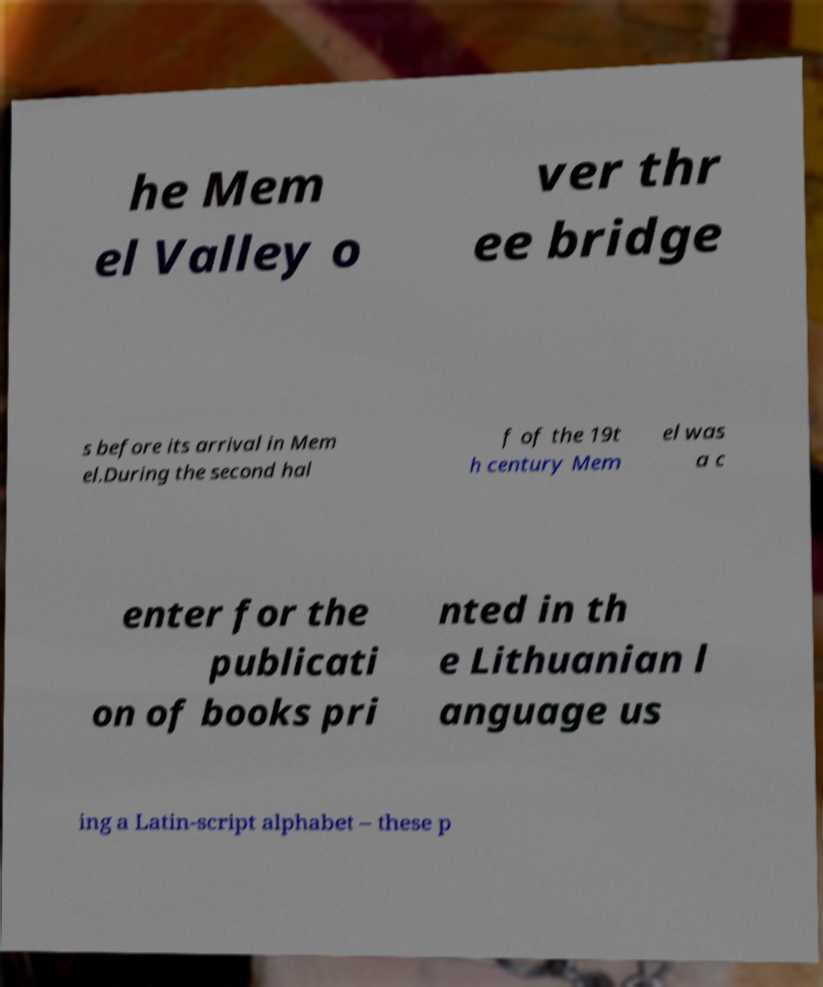Could you assist in decoding the text presented in this image and type it out clearly? he Mem el Valley o ver thr ee bridge s before its arrival in Mem el.During the second hal f of the 19t h century Mem el was a c enter for the publicati on of books pri nted in th e Lithuanian l anguage us ing a Latin-script alphabet – these p 